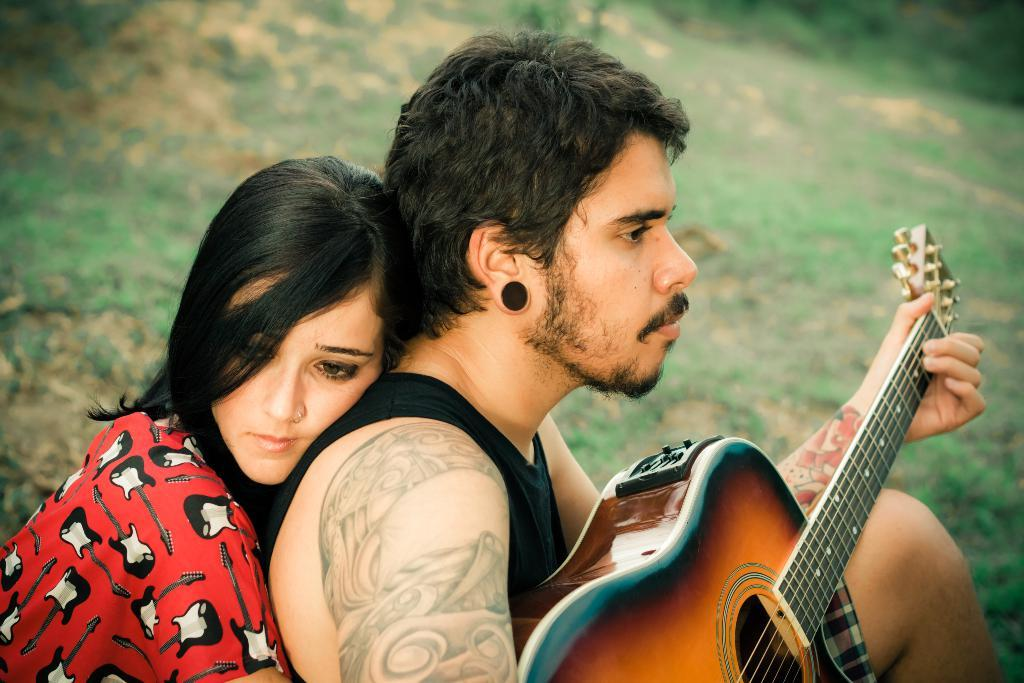Who is present in the image? There is a woman and a man in the image. What is the woman doing in the image? The woman is hugging a man from behind. What is the man doing in the image? The man is playing a guitar. What type of environment is depicted in the image? There is grass in the image, suggesting an outdoor setting. Can you see any toads hopping around in the image? There are no toads present in the image. What color is the sky in the image? The provided facts do not mention the sky, so we cannot determine its color from the image. 